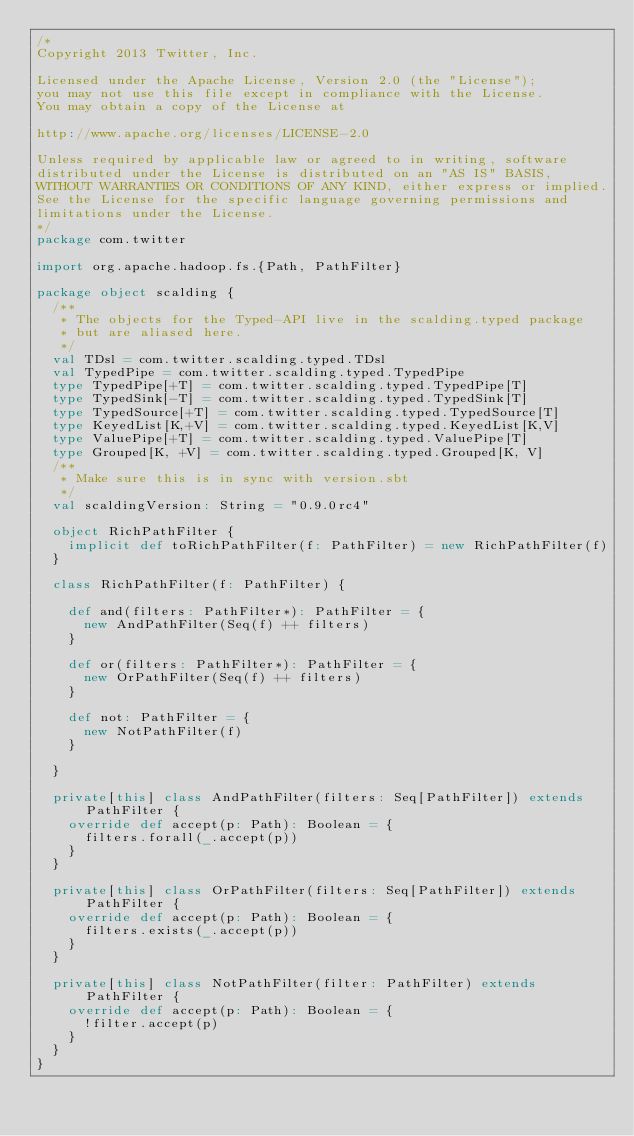<code> <loc_0><loc_0><loc_500><loc_500><_Scala_>/*
Copyright 2013 Twitter, Inc.

Licensed under the Apache License, Version 2.0 (the "License");
you may not use this file except in compliance with the License.
You may obtain a copy of the License at

http://www.apache.org/licenses/LICENSE-2.0

Unless required by applicable law or agreed to in writing, software
distributed under the License is distributed on an "AS IS" BASIS,
WITHOUT WARRANTIES OR CONDITIONS OF ANY KIND, either express or implied.
See the License for the specific language governing permissions and
limitations under the License.
*/
package com.twitter

import org.apache.hadoop.fs.{Path, PathFilter}

package object scalding {
  /**
   * The objects for the Typed-API live in the scalding.typed package
   * but are aliased here.
   */
  val TDsl = com.twitter.scalding.typed.TDsl
  val TypedPipe = com.twitter.scalding.typed.TypedPipe
  type TypedPipe[+T] = com.twitter.scalding.typed.TypedPipe[T]
  type TypedSink[-T] = com.twitter.scalding.typed.TypedSink[T]
  type TypedSource[+T] = com.twitter.scalding.typed.TypedSource[T]
  type KeyedList[K,+V] = com.twitter.scalding.typed.KeyedList[K,V]
  type ValuePipe[+T] = com.twitter.scalding.typed.ValuePipe[T]
  type Grouped[K, +V] = com.twitter.scalding.typed.Grouped[K, V]
  /**
   * Make sure this is in sync with version.sbt
   */
  val scaldingVersion: String = "0.9.0rc4"

  object RichPathFilter {
    implicit def toRichPathFilter(f: PathFilter) = new RichPathFilter(f)
  }

  class RichPathFilter(f: PathFilter) {

    def and(filters: PathFilter*): PathFilter = {
      new AndPathFilter(Seq(f) ++ filters)
    }

    def or(filters: PathFilter*): PathFilter = {
      new OrPathFilter(Seq(f) ++ filters)
    }

    def not: PathFilter = {
      new NotPathFilter(f)
    }

  }

  private[this] class AndPathFilter(filters: Seq[PathFilter]) extends PathFilter {
    override def accept(p: Path): Boolean = {
      filters.forall(_.accept(p))
    }
  }

  private[this] class OrPathFilter(filters: Seq[PathFilter]) extends PathFilter {
    override def accept(p: Path): Boolean = {
      filters.exists(_.accept(p))
    }
  }

  private[this] class NotPathFilter(filter: PathFilter) extends PathFilter {
    override def accept(p: Path): Boolean = {
      !filter.accept(p)
    }
  }
}
</code> 